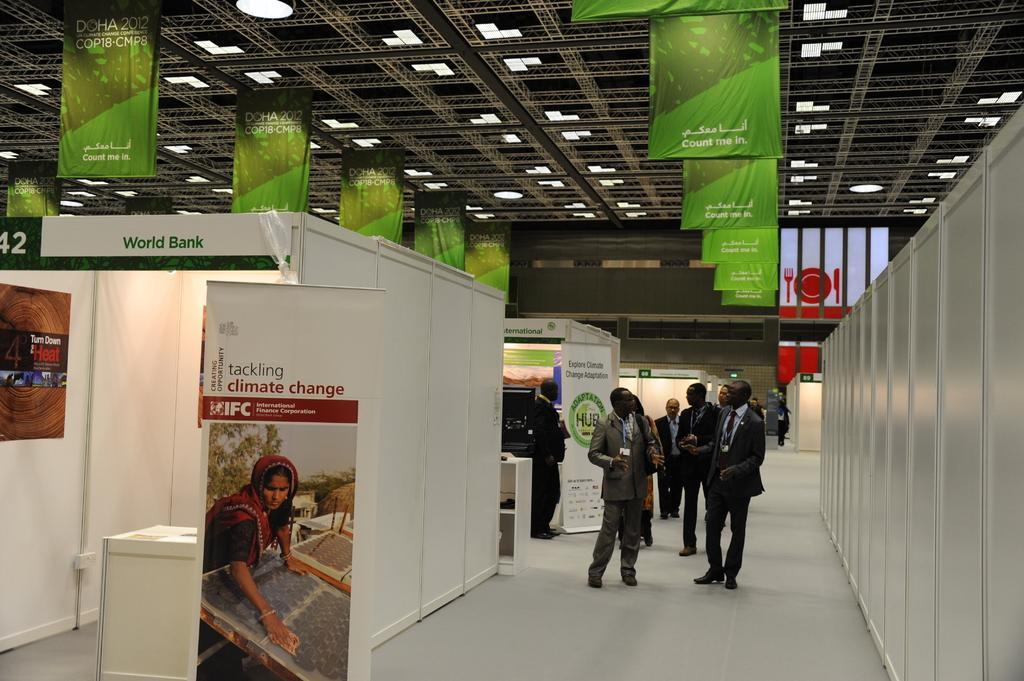Could you give a brief overview of what you see in this image? In this image there are some persons standing at right side of this image and there are some lights are arranged at top of this image. There are some cabins as we can see at left side of this image and there is a floor at bottom of this image. 